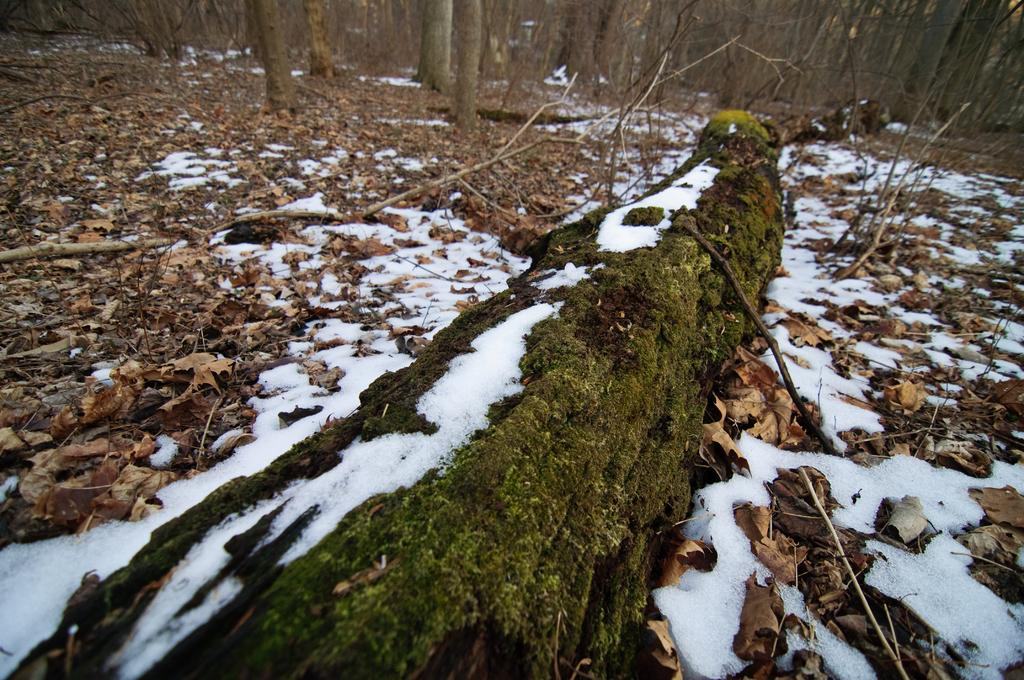What type of weather condition is depicted in the image? There is snow in the image, indicating a cold and wintry scene. What can be seen on the ground in the image? There are dried leaves in the image, suggesting that the leaves have fallen from the trees. What type of vegetation is present in the image? There are trees in the image. What type of map is being offered by the kittens in the image? There are no kittens or maps present in the image. 